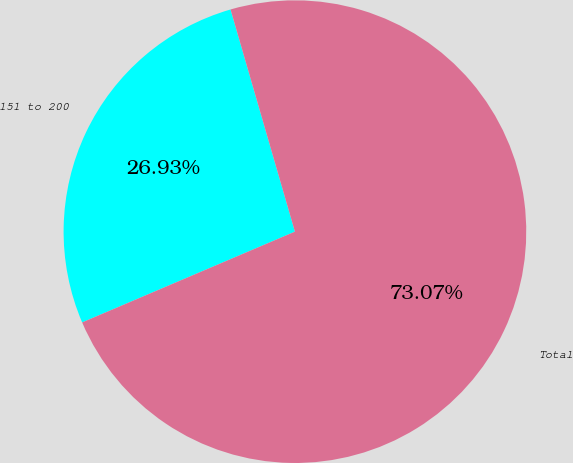Convert chart to OTSL. <chart><loc_0><loc_0><loc_500><loc_500><pie_chart><fcel>151 to 200<fcel>Total<nl><fcel>26.93%<fcel>73.07%<nl></chart> 